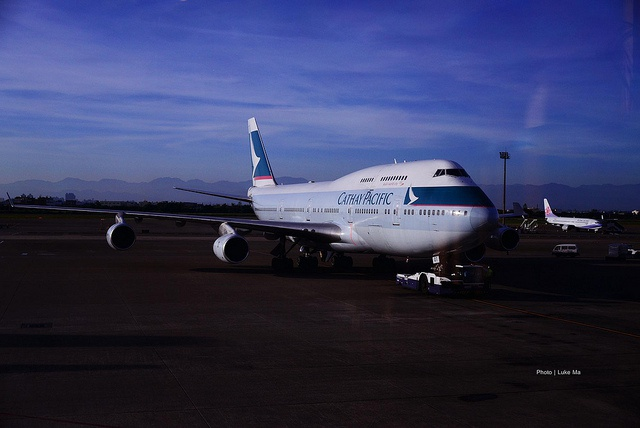Describe the objects in this image and their specific colors. I can see airplane in darkblue, black, darkgray, and navy tones, bus in darkblue, black, lightgray, darkgray, and gray tones, airplane in darkblue, darkgray, black, and lightgray tones, and truck in darkblue, black, and gray tones in this image. 